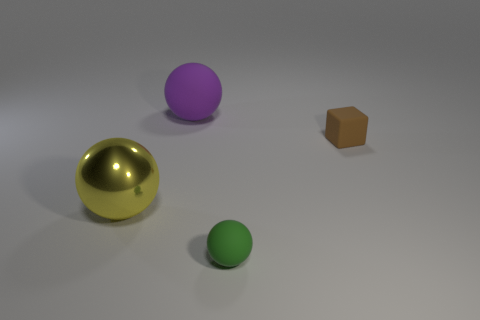Add 4 green rubber things. How many objects exist? 8 Subtract all blocks. How many objects are left? 3 Add 3 brown matte blocks. How many brown matte blocks exist? 4 Subtract 0 gray spheres. How many objects are left? 4 Subtract all shiny spheres. Subtract all spheres. How many objects are left? 0 Add 1 small brown rubber cubes. How many small brown rubber cubes are left? 2 